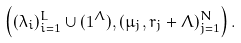Convert formula to latex. <formula><loc_0><loc_0><loc_500><loc_500>\left ( ( \lambda _ { i } ) _ { i = 1 } ^ { L } \cup ( 1 ^ { \Lambda } ) , ( \mu _ { j } , r _ { j } + \Lambda ) _ { j = 1 } ^ { N } \right ) .</formula> 